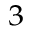Convert formula to latex. <formula><loc_0><loc_0><loc_500><loc_500>^ { 3 }</formula> 